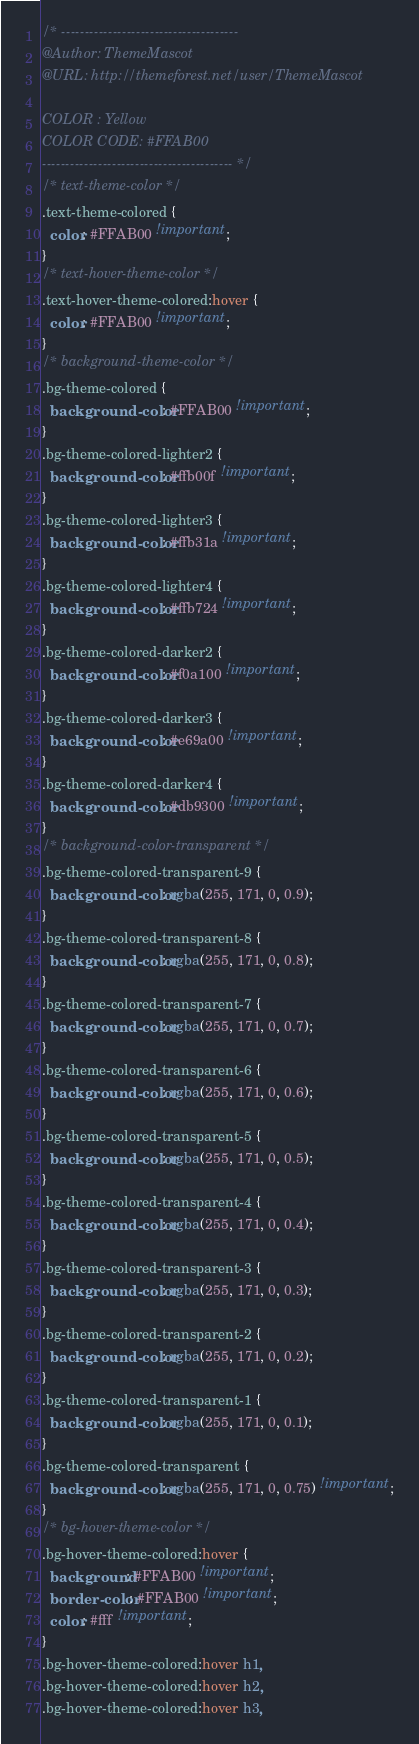Convert code to text. <code><loc_0><loc_0><loc_500><loc_500><_CSS_>/* --------------------------------------
@Author: ThemeMascot
@URL: http://themeforest.net/user/ThemeMascot

COLOR : Yellow
COLOR CODE: #FFAB00
----------------------------------------- */
/* text-theme-color */
.text-theme-colored {
  color: #FFAB00 !important;
}
/* text-hover-theme-color */
.text-hover-theme-colored:hover {
  color: #FFAB00 !important;
}
/* background-theme-color */
.bg-theme-colored {
  background-color: #FFAB00 !important;
}
.bg-theme-colored-lighter2 {
  background-color: #ffb00f !important;
}
.bg-theme-colored-lighter3 {
  background-color: #ffb31a !important;
}
.bg-theme-colored-lighter4 {
  background-color: #ffb724 !important;
}
.bg-theme-colored-darker2 {
  background-color: #f0a100 !important;
}
.bg-theme-colored-darker3 {
  background-color: #e69a00 !important;
}
.bg-theme-colored-darker4 {
  background-color: #db9300 !important;
}
/* background-color-transparent */
.bg-theme-colored-transparent-9 {
  background-color: rgba(255, 171, 0, 0.9);
}
.bg-theme-colored-transparent-8 {
  background-color: rgba(255, 171, 0, 0.8);
}
.bg-theme-colored-transparent-7 {
  background-color: rgba(255, 171, 0, 0.7);
}
.bg-theme-colored-transparent-6 {
  background-color: rgba(255, 171, 0, 0.6);
}
.bg-theme-colored-transparent-5 {
  background-color: rgba(255, 171, 0, 0.5);
}
.bg-theme-colored-transparent-4 {
  background-color: rgba(255, 171, 0, 0.4);
}
.bg-theme-colored-transparent-3 {
  background-color: rgba(255, 171, 0, 0.3);
}
.bg-theme-colored-transparent-2 {
  background-color: rgba(255, 171, 0, 0.2);
}
.bg-theme-colored-transparent-1 {
  background-color: rgba(255, 171, 0, 0.1);
}
.bg-theme-colored-transparent {
  background-color: rgba(255, 171, 0, 0.75) !important;
}
/* bg-hover-theme-color */
.bg-hover-theme-colored:hover {
  background: #FFAB00 !important;
  border-color: #FFAB00 !important;
  color: #fff !important;
}
.bg-hover-theme-colored:hover h1,
.bg-hover-theme-colored:hover h2,
.bg-hover-theme-colored:hover h3,</code> 